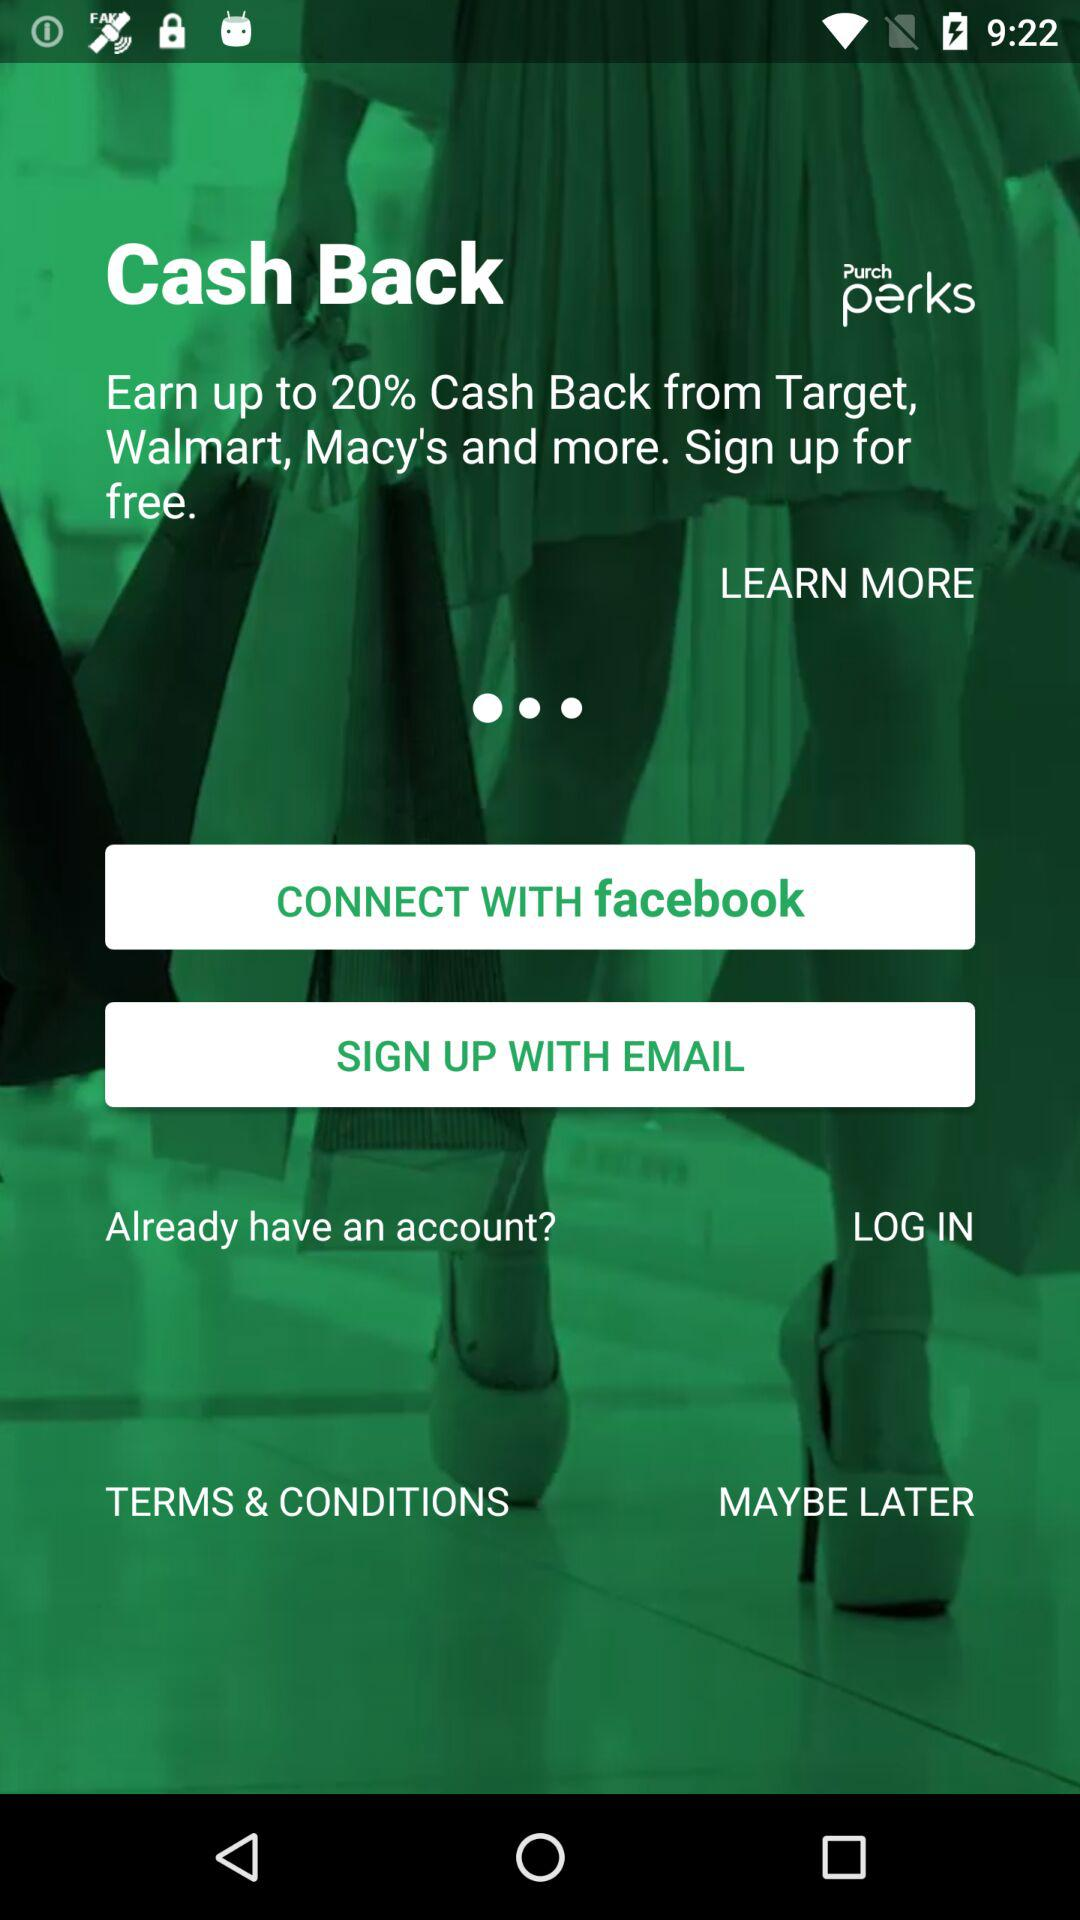What is the status of "TERMS & CONDITIONS"?
When the provided information is insufficient, respond with <no answer>. <no answer> 